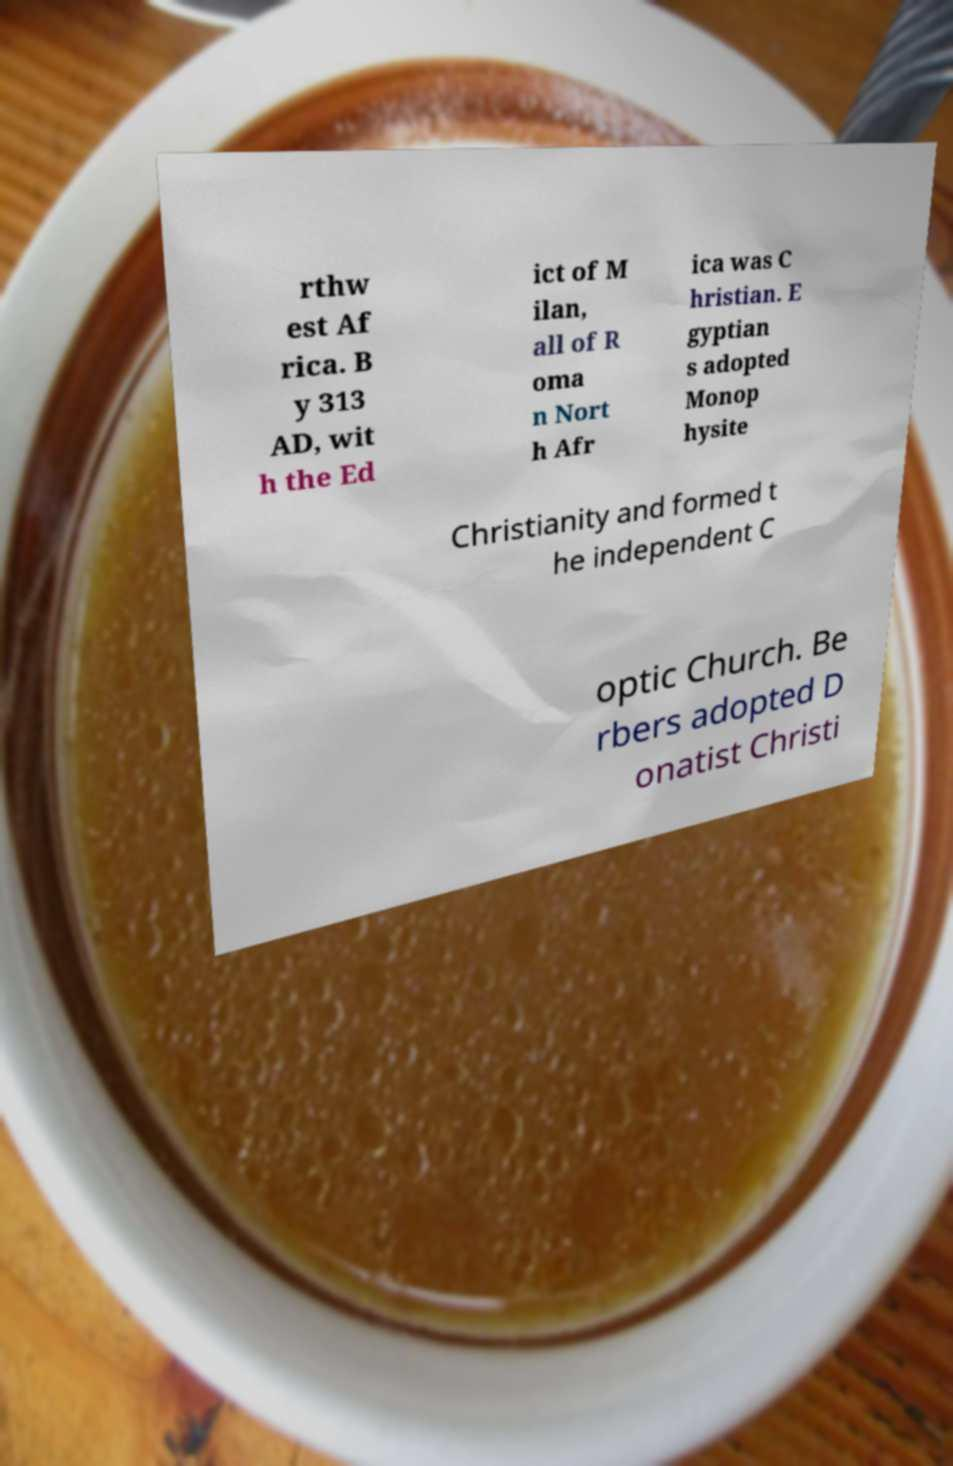There's text embedded in this image that I need extracted. Can you transcribe it verbatim? rthw est Af rica. B y 313 AD, wit h the Ed ict of M ilan, all of R oma n Nort h Afr ica was C hristian. E gyptian s adopted Monop hysite Christianity and formed t he independent C optic Church. Be rbers adopted D onatist Christi 